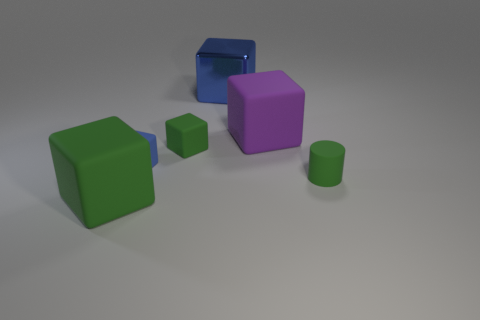What is the material of the big thing that is the same color as the small cylinder?
Ensure brevity in your answer.  Rubber. What number of tiny things are either purple rubber things or red spheres?
Offer a very short reply. 0. Are there any other metallic cylinders that have the same color as the tiny cylinder?
Keep it short and to the point. No. Do the block in front of the green rubber cylinder and the tiny cylinder have the same color?
Your response must be concise. Yes. How many things are big matte cubes left of the purple matte cube or large purple matte blocks?
Ensure brevity in your answer.  2. Is the number of green cylinders that are in front of the large blue metallic object greater than the number of shiny objects that are behind the tiny green cylinder?
Give a very brief answer. No. Is the material of the green cylinder the same as the purple block?
Give a very brief answer. Yes. What shape is the green rubber thing that is in front of the small blue object and on the right side of the large green block?
Your response must be concise. Cylinder. There is a small blue thing that is made of the same material as the big purple object; what shape is it?
Provide a short and direct response. Cube. Are any matte objects visible?
Your response must be concise. Yes. 